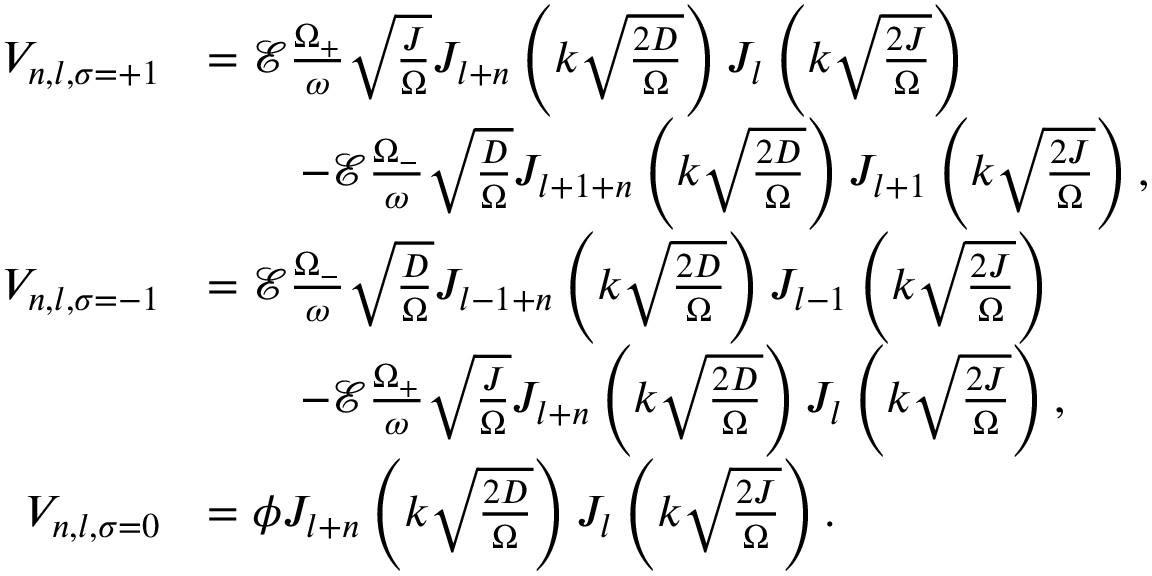<formula> <loc_0><loc_0><loc_500><loc_500>\begin{array} { r l } { V _ { n , l , \sigma = + 1 } } & { = \mathcal { E } \frac { \Omega _ { + } } { \omega } \sqrt { \frac { J } { \Omega } } J _ { l + n } \left ( k \sqrt { \frac { 2 D } { \Omega } } \right ) J _ { l } \left ( k \sqrt { \frac { 2 J } { \Omega } } \right ) } \\ & { \quad - \mathcal { E } \frac { \Omega _ { - } } { \omega } \sqrt { \frac { D } { \Omega } } J _ { l + 1 + n } \left ( k \sqrt { \frac { 2 D } { \Omega } } \right ) J _ { l + 1 } \left ( k \sqrt { \frac { 2 J } { \Omega } } \right ) , } \\ { V _ { n , l , \sigma = - 1 } } & { = \mathcal { E } \frac { \Omega _ { - } } { \omega } \sqrt { \frac { D } { \Omega } } J _ { l - 1 + n } \left ( k \sqrt { \frac { 2 D } { \Omega } } \right ) J _ { l - 1 } \left ( k \sqrt { \frac { 2 J } { \Omega } } \right ) } \\ & { \quad - \mathcal { E } \frac { \Omega _ { + } } { \omega } \sqrt { \frac { J } { \Omega } } J _ { l + n } \left ( k \sqrt { \frac { 2 D } { \Omega } } \right ) J _ { l } \left ( k \sqrt { \frac { 2 J } { \Omega } } \right ) , } \\ { V _ { n , l , \sigma = 0 } } & { = \phi J _ { l + n } \left ( k \sqrt { \frac { 2 D } { \Omega } } \right ) J _ { l } \left ( k \sqrt { \frac { 2 J } { \Omega } } \right ) . } \end{array}</formula> 